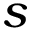Convert formula to latex. <formula><loc_0><loc_0><loc_500><loc_500>s</formula> 